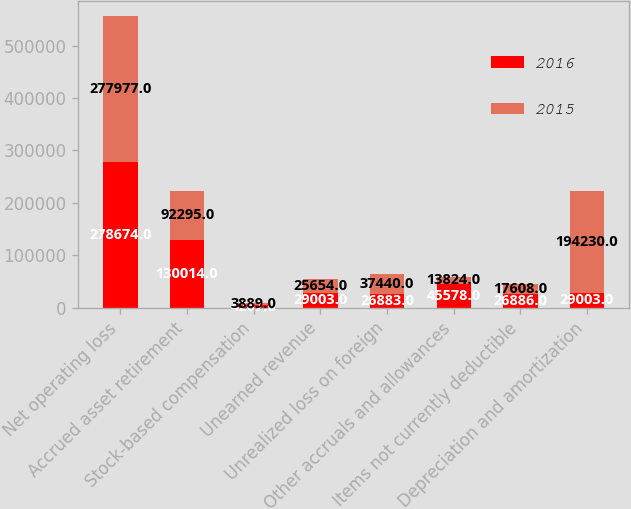<chart> <loc_0><loc_0><loc_500><loc_500><stacked_bar_chart><ecel><fcel>Net operating loss<fcel>Accrued asset retirement<fcel>Stock-based compensation<fcel>Unearned revenue<fcel>Unrealized loss on foreign<fcel>Other accruals and allowances<fcel>Items not currently deductible<fcel>Depreciation and amortization<nl><fcel>2016<fcel>278674<fcel>130014<fcel>4267<fcel>29003<fcel>26883<fcel>45578<fcel>26886<fcel>29003<nl><fcel>2015<fcel>277977<fcel>92295<fcel>3889<fcel>25654<fcel>37440<fcel>13824<fcel>17608<fcel>194230<nl></chart> 